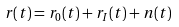<formula> <loc_0><loc_0><loc_500><loc_500>r ( t ) = r _ { 0 } ( t ) + r _ { I } ( t ) + n ( t )</formula> 